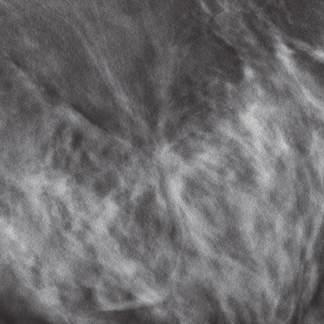do lobular carcinomas appear as relatively subtle, irregular masses in mammograms?
Answer the question using a single word or phrase. Yes 